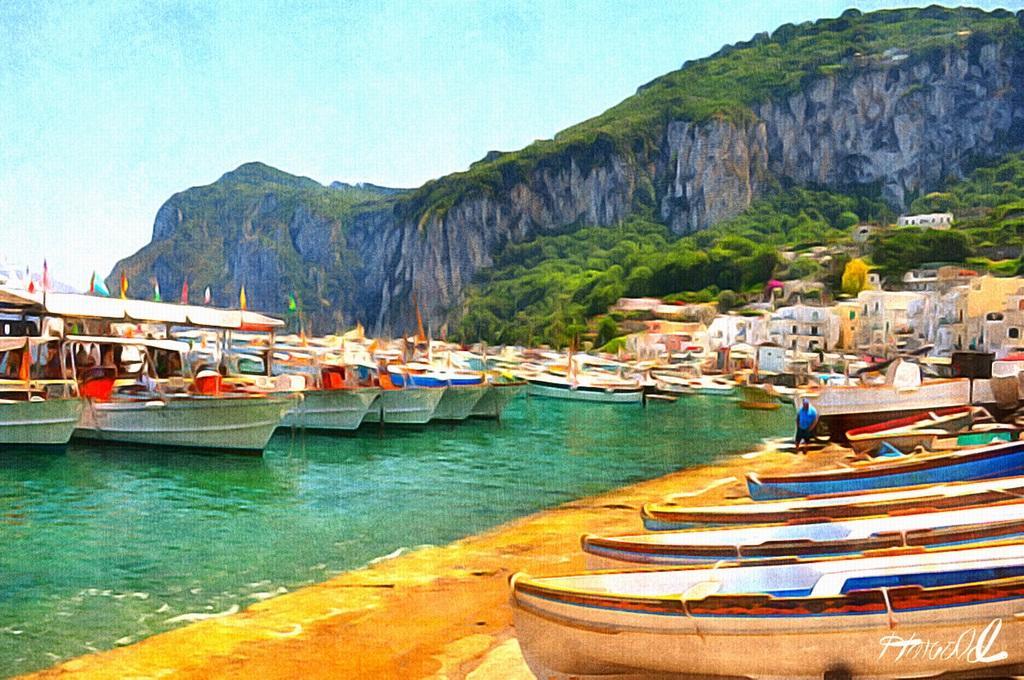Could you give a brief overview of what you see in this image? In this picture we can see the painting of boats. Some boats are on the path and some boats are on the water and a person is standing on the path. Behind the boats there are buildings, trees, hill and the sky. On the image it is written something. 